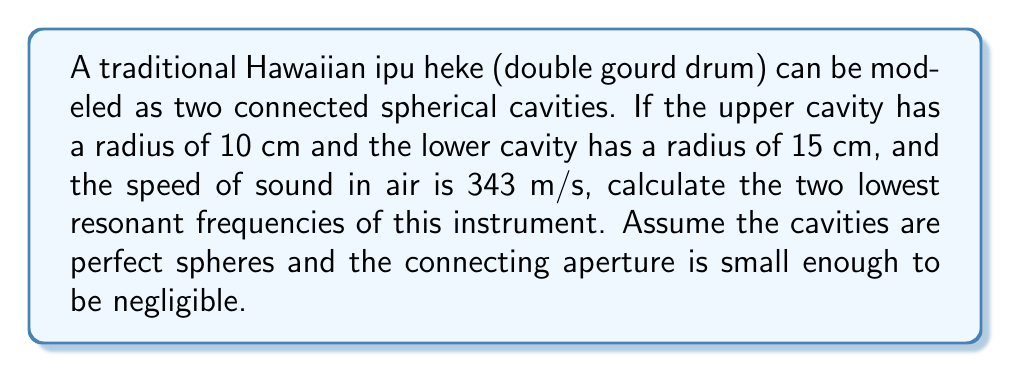Could you help me with this problem? To solve this problem, we'll use the equation for the resonant frequencies of a spherical cavity:

$$f_n = \frac{c}{2\pi a}\sqrt{n(n+1)}$$

Where:
$f_n$ is the nth resonant frequency
$c$ is the speed of sound in air
$a$ is the radius of the sphere
$n$ is the mode number (1, 2, 3, ...)

Step 1: Calculate the lowest resonant frequency ($n=1$) for the upper cavity:
$$f_1 = \frac{343}{2\pi(0.10)}\sqrt{1(1+1)} = \frac{343}{0.2\pi}\sqrt{2} \approx 1214.8 \text{ Hz}$$

Step 2: Calculate the lowest resonant frequency ($n=1$) for the lower cavity:
$$f_1 = \frac{343}{2\pi(0.15)}\sqrt{1(1+1)} = \frac{343}{0.3\pi}\sqrt{2} \approx 809.9 \text{ Hz}$$

Step 3: The two lowest resonant frequencies of the ipu heke will be the lowest frequencies from each cavity. Therefore, the two lowest resonant frequencies are approximately 809.9 Hz and 1214.8 Hz.
Answer: 809.9 Hz and 1214.8 Hz 